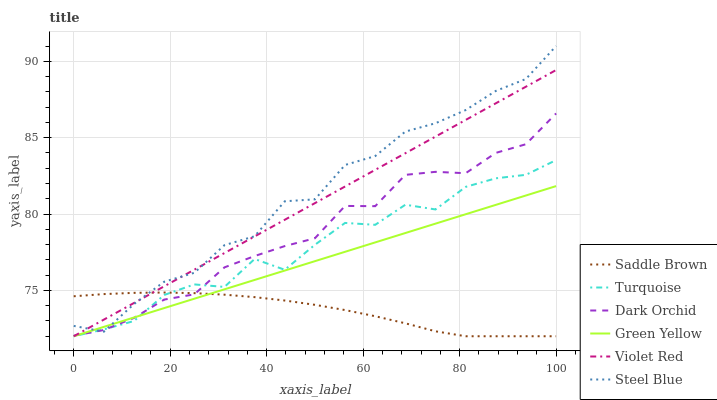Does Saddle Brown have the minimum area under the curve?
Answer yes or no. Yes. Does Steel Blue have the maximum area under the curve?
Answer yes or no. Yes. Does Turquoise have the minimum area under the curve?
Answer yes or no. No. Does Turquoise have the maximum area under the curve?
Answer yes or no. No. Is Green Yellow the smoothest?
Answer yes or no. Yes. Is Turquoise the roughest?
Answer yes or no. Yes. Is Dark Orchid the smoothest?
Answer yes or no. No. Is Dark Orchid the roughest?
Answer yes or no. No. Does Violet Red have the lowest value?
Answer yes or no. Yes. Does Dark Orchid have the lowest value?
Answer yes or no. No. Does Steel Blue have the highest value?
Answer yes or no. Yes. Does Turquoise have the highest value?
Answer yes or no. No. Does Steel Blue intersect Dark Orchid?
Answer yes or no. Yes. Is Steel Blue less than Dark Orchid?
Answer yes or no. No. Is Steel Blue greater than Dark Orchid?
Answer yes or no. No. 